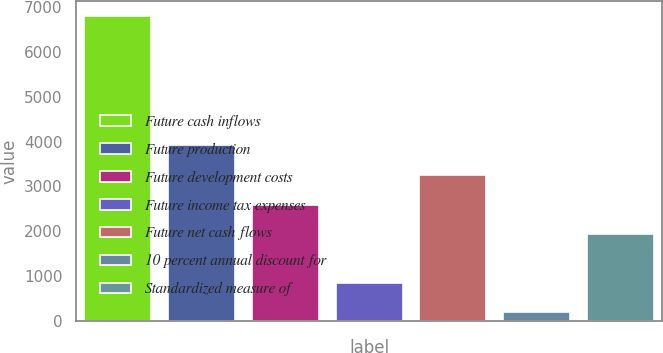<chart> <loc_0><loc_0><loc_500><loc_500><bar_chart><fcel>Future cash inflows<fcel>Future production<fcel>Future development costs<fcel>Future income tax expenses<fcel>Future net cash flows<fcel>10 percent annual discount for<fcel>Standardized measure of<nl><fcel>6802<fcel>3915.3<fcel>2593.1<fcel>852.1<fcel>3254.2<fcel>191<fcel>1932<nl></chart> 